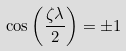<formula> <loc_0><loc_0><loc_500><loc_500>\cos \left ( \frac { \zeta \lambda } { 2 } \right ) = \pm 1</formula> 